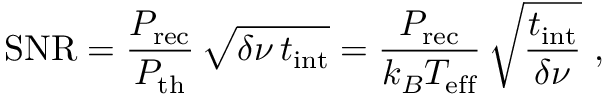Convert formula to latex. <formula><loc_0><loc_0><loc_500><loc_500>S N R = \frac { P _ { r e c } } { P _ { t h } } \, \sqrt { \delta \nu \, t _ { i n t } } = \frac { P _ { r e c } } { k _ { B } T _ { e f f } } \, \sqrt { \frac { t _ { i n t } } { \delta \nu } } ,</formula> 